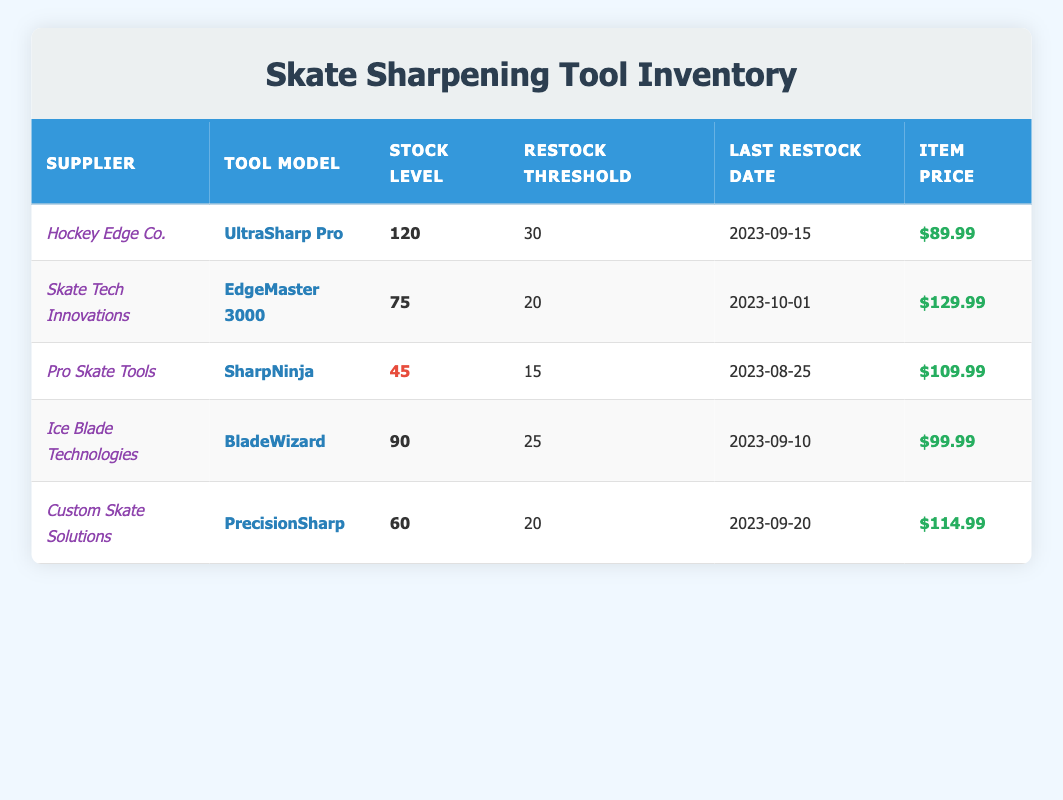What is the stock level for the "SharpNinja" tool model? The table lists the stock level for the "SharpNinja" tool model under the supplier "Pro Skate Tools," which is 45.
Answer: 45 How many tools need to be restocked for "EdgeMaster 3000"? The restock threshold for the "EdgeMaster 3000" model is 20, and the current stock level is 75, which means it does not need to be restocked and needs zero tools to reach the threshold.
Answer: 0 Which tool model has the highest stock level? By comparing the stock levels of all tool models in the table, "UltraSharp Pro" from "Hockey Edge Co." has the highest stock level at 120.
Answer: UltraSharp Pro Is there any tool model that has a stock level below the restock threshold? The "SharpNinja" from "Pro Skate Tools" has a stock level of 45, which is above its restock threshold of 15. All other models also have stock levels above their thresholds. Therefore, no tool model is below the restock threshold.
Answer: No What is the average item price of all tool models in the inventory? The item prices are $89.99, $129.99, $109.99, $99.99, and $114.99. Summing these gives $543.95. Dividing this by the 5 models gives an average price of $108.79.
Answer: 108.79 What is the total stock level of tools from "Ice Blade Technologies" and "Custom Skate Solutions"? The stock level for "BladeWizard" from "Ice Blade Technologies" is 90, and for "PrecisionSharp" from "Custom Skate Solutions" it is 60. Adding these two gives a total stock level of 150.
Answer: 150 When was the last restock date for tools with a stock level less than 60? Among the listed tools, "SharpNinja" is the only model with a stock level of 45, which had its last restock date on 2023-08-25.
Answer: 2023-08-25 Which supplier has a tool model priced above $120? The "EdgeMaster 3000" from "Skate Tech Innovations" is priced at $129.99, which is above $120. Therefore, "Skate Tech Innovations" has a model priced above that amount.
Answer: Skate Tech Innovations Does "Hockey Edge Co." have a tool model with a restock threshold of 30? The "UltraSharp Pro" from "Hockey Edge Co." has a restock threshold of 30. Therefore, the answer is yes.
Answer: Yes 